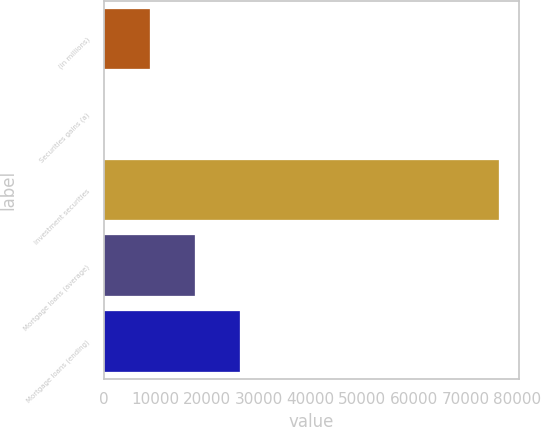<chart> <loc_0><loc_0><loc_500><loc_500><bar_chart><fcel>(in millions)<fcel>Securities gains (a)<fcel>Investment securities<fcel>Mortgage loans (average)<fcel>Mortgage loans (ending)<nl><fcel>8837<fcel>37<fcel>76480<fcel>17637<fcel>26437<nl></chart> 